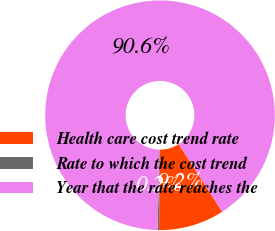<chart> <loc_0><loc_0><loc_500><loc_500><pie_chart><fcel>Health care cost trend rate<fcel>Rate to which the cost trend<fcel>Year that the rate reaches the<nl><fcel>9.24%<fcel>0.2%<fcel>90.56%<nl></chart> 